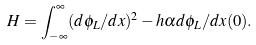Convert formula to latex. <formula><loc_0><loc_0><loc_500><loc_500>H = \int _ { - \infty } ^ { \infty } ( d \phi _ { L } / d x ) ^ { 2 } - h \alpha d \phi _ { L } / d x ( 0 ) .</formula> 